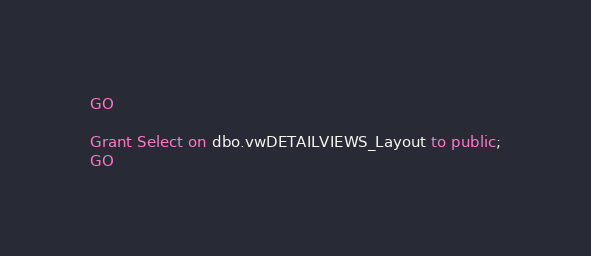Convert code to text. <code><loc_0><loc_0><loc_500><loc_500><_SQL_>
GO

Grant Select on dbo.vwDETAILVIEWS_Layout to public;
GO

</code> 